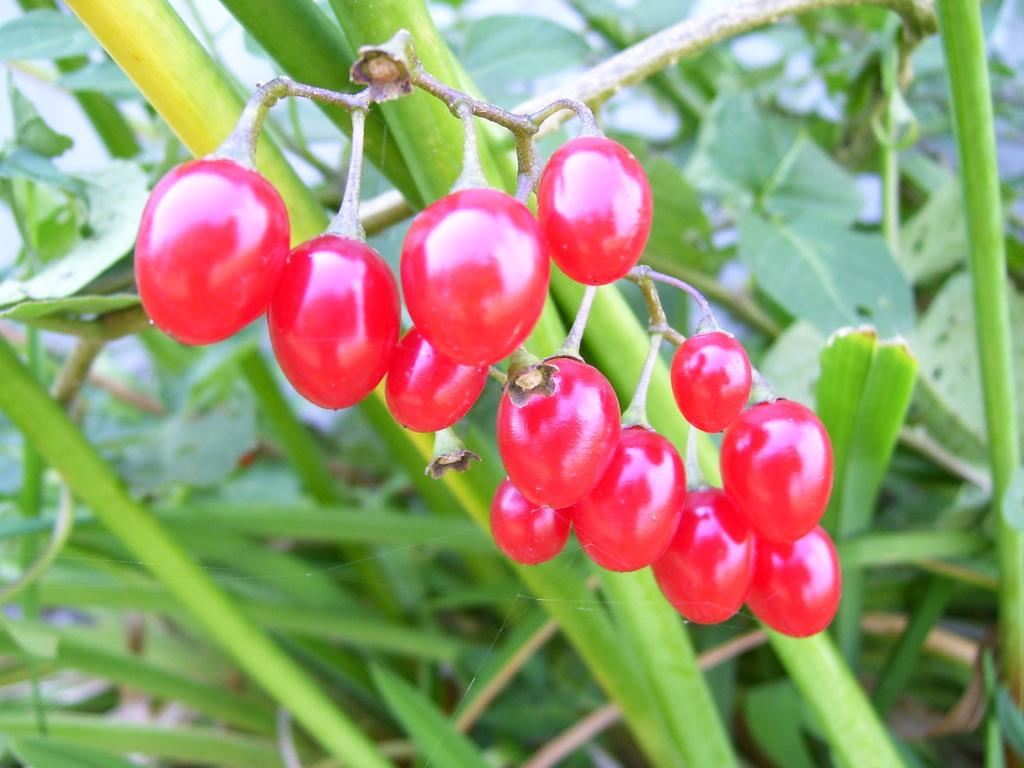What type of vegetation is present in the image? There is grass in the image. What color are the fruits in the image? The fruits in the image are pink. What theory does the queen propose in the image? There is no queen or any theory present in the image; it only features grass and pink fruits. 